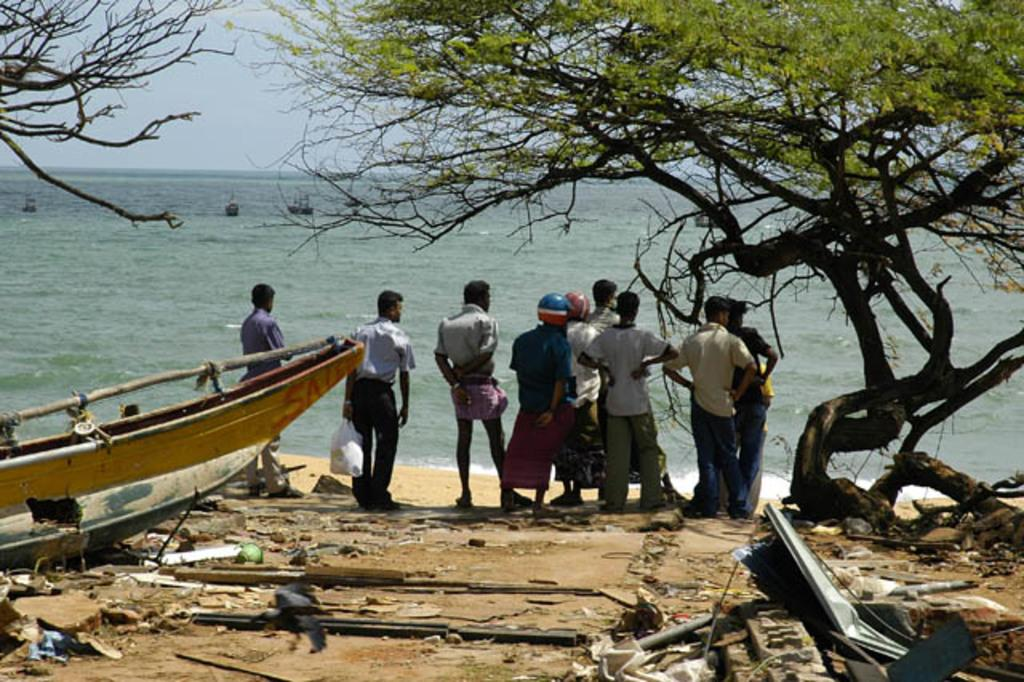What is the background of the image? The men are standing in front of the ocean, and there are ships visible in the image. What can be seen on the land? There are trees and garbage on the land. What is visible in the sky? The sky is visible in the image. How many frogs are sitting on the spoon in the image? There are no frogs or spoons present in the image. What color is the crayon used to draw on the sand in the image? There is no crayon or drawing on the sand in the image. 